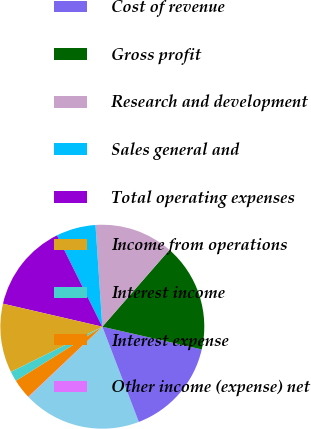Convert chart to OTSL. <chart><loc_0><loc_0><loc_500><loc_500><pie_chart><fcel>Revenue<fcel>Cost of revenue<fcel>Gross profit<fcel>Research and development<fcel>Sales general and<fcel>Total operating expenses<fcel>Income from operations<fcel>Interest income<fcel>Interest expense<fcel>Other income (expense) net<nl><fcel>18.71%<fcel>15.6%<fcel>17.15%<fcel>12.49%<fcel>6.27%<fcel>14.04%<fcel>10.93%<fcel>1.6%<fcel>3.16%<fcel>0.05%<nl></chart> 